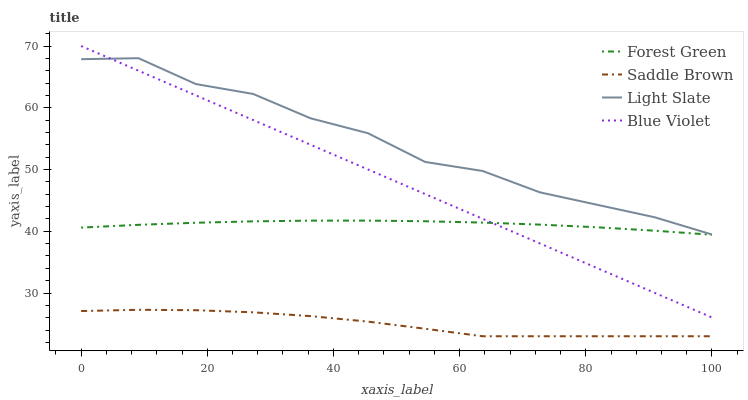Does Saddle Brown have the minimum area under the curve?
Answer yes or no. Yes. Does Light Slate have the maximum area under the curve?
Answer yes or no. Yes. Does Forest Green have the minimum area under the curve?
Answer yes or no. No. Does Forest Green have the maximum area under the curve?
Answer yes or no. No. Is Blue Violet the smoothest?
Answer yes or no. Yes. Is Light Slate the roughest?
Answer yes or no. Yes. Is Forest Green the smoothest?
Answer yes or no. No. Is Forest Green the roughest?
Answer yes or no. No. Does Saddle Brown have the lowest value?
Answer yes or no. Yes. Does Forest Green have the lowest value?
Answer yes or no. No. Does Blue Violet have the highest value?
Answer yes or no. Yes. Does Forest Green have the highest value?
Answer yes or no. No. Is Saddle Brown less than Blue Violet?
Answer yes or no. Yes. Is Blue Violet greater than Saddle Brown?
Answer yes or no. Yes. Does Light Slate intersect Blue Violet?
Answer yes or no. Yes. Is Light Slate less than Blue Violet?
Answer yes or no. No. Is Light Slate greater than Blue Violet?
Answer yes or no. No. Does Saddle Brown intersect Blue Violet?
Answer yes or no. No. 